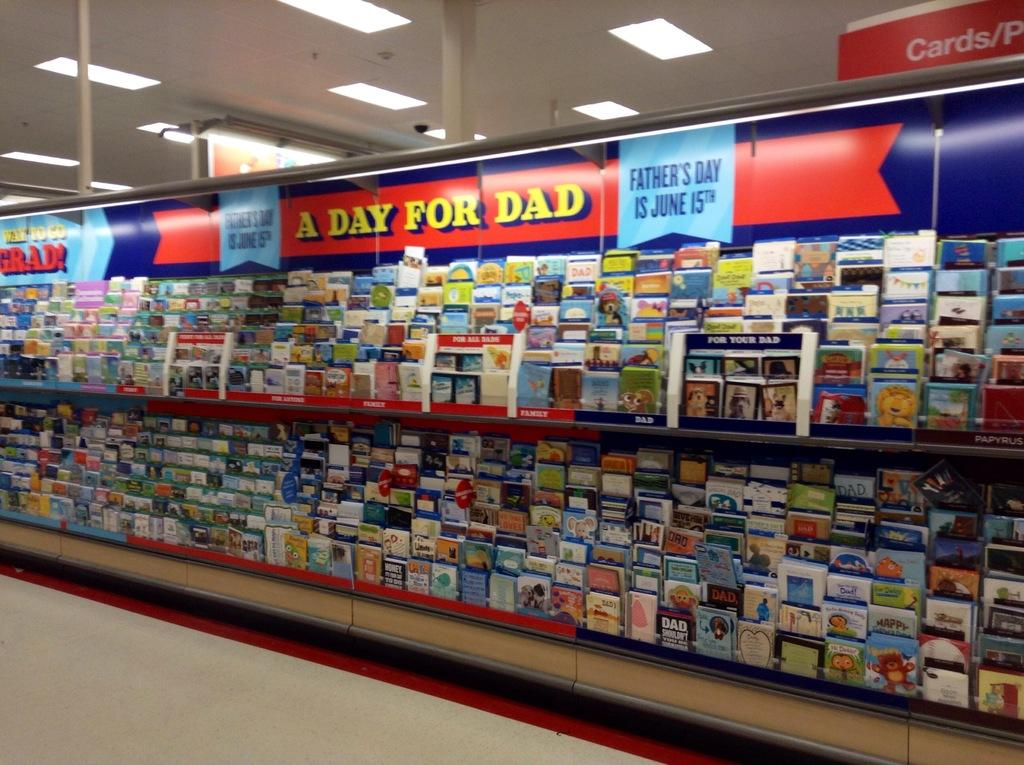<image>
Offer a succinct explanation of the picture presented. A banner for A Day for Dad is over the card display. 